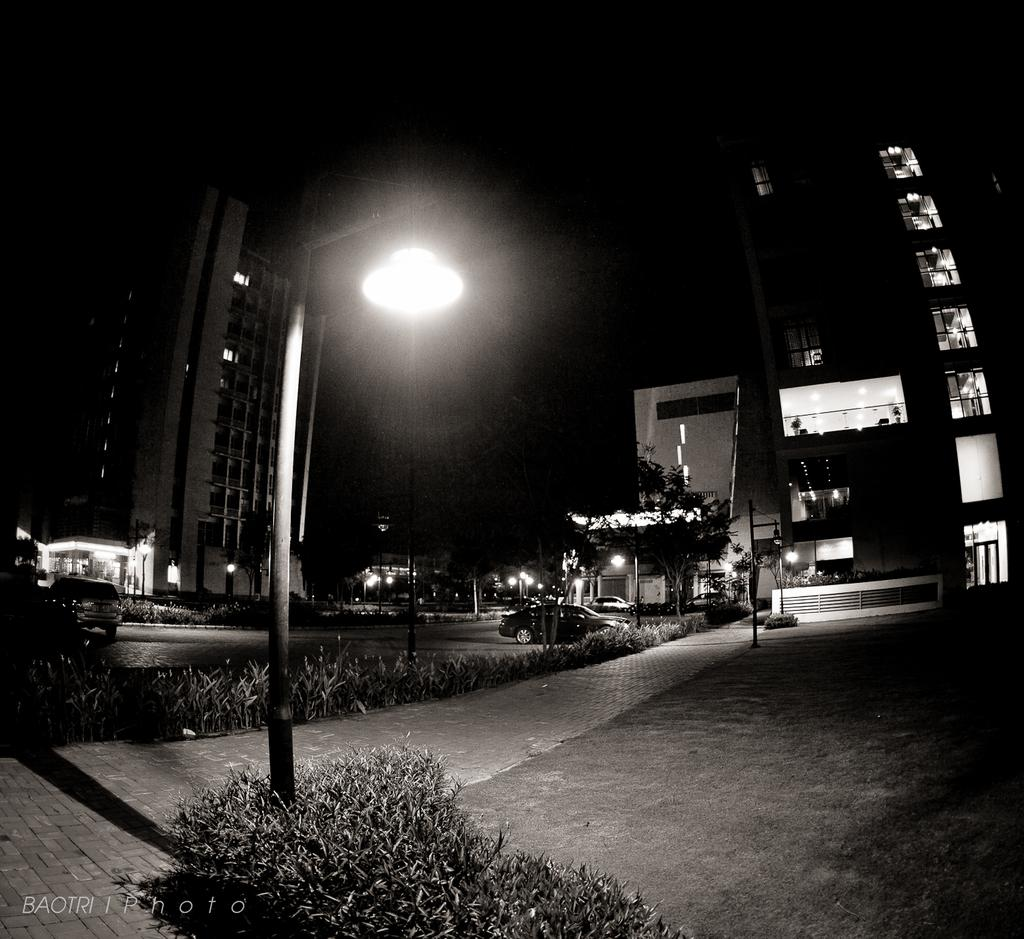What is the color scheme of the image? The image is black and white. What type of natural elements can be seen in the image? There are trees and plants in the image. What man-made structures are present in the image? There are poles and lights in the image. What is the primary pathway visible in the image? There is a walkway at the bottom of the image. Where is the hydrant located in the image? There is no hydrant present in the image. What team is responsible for maintaining the plants in the image? The image does not provide information about a team responsible for maintaining the plants. 